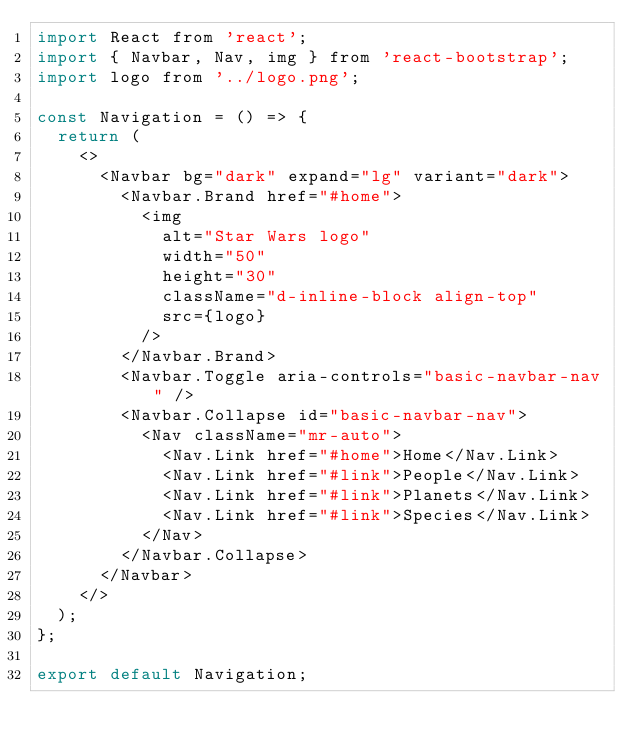Convert code to text. <code><loc_0><loc_0><loc_500><loc_500><_JavaScript_>import React from 'react';
import { Navbar, Nav, img } from 'react-bootstrap';
import logo from '../logo.png';

const Navigation = () => {
  return (
    <>
      <Navbar bg="dark" expand="lg" variant="dark">
        <Navbar.Brand href="#home">
          <img
            alt="Star Wars logo"
            width="50"
            height="30"
            className="d-inline-block align-top"
            src={logo}
          />
        </Navbar.Brand>
        <Navbar.Toggle aria-controls="basic-navbar-nav" />
        <Navbar.Collapse id="basic-navbar-nav">
          <Nav className="mr-auto">
            <Nav.Link href="#home">Home</Nav.Link>
            <Nav.Link href="#link">People</Nav.Link>
            <Nav.Link href="#link">Planets</Nav.Link>
            <Nav.Link href="#link">Species</Nav.Link>
          </Nav>
        </Navbar.Collapse>
      </Navbar>
    </>
  );
};

export default Navigation;
</code> 